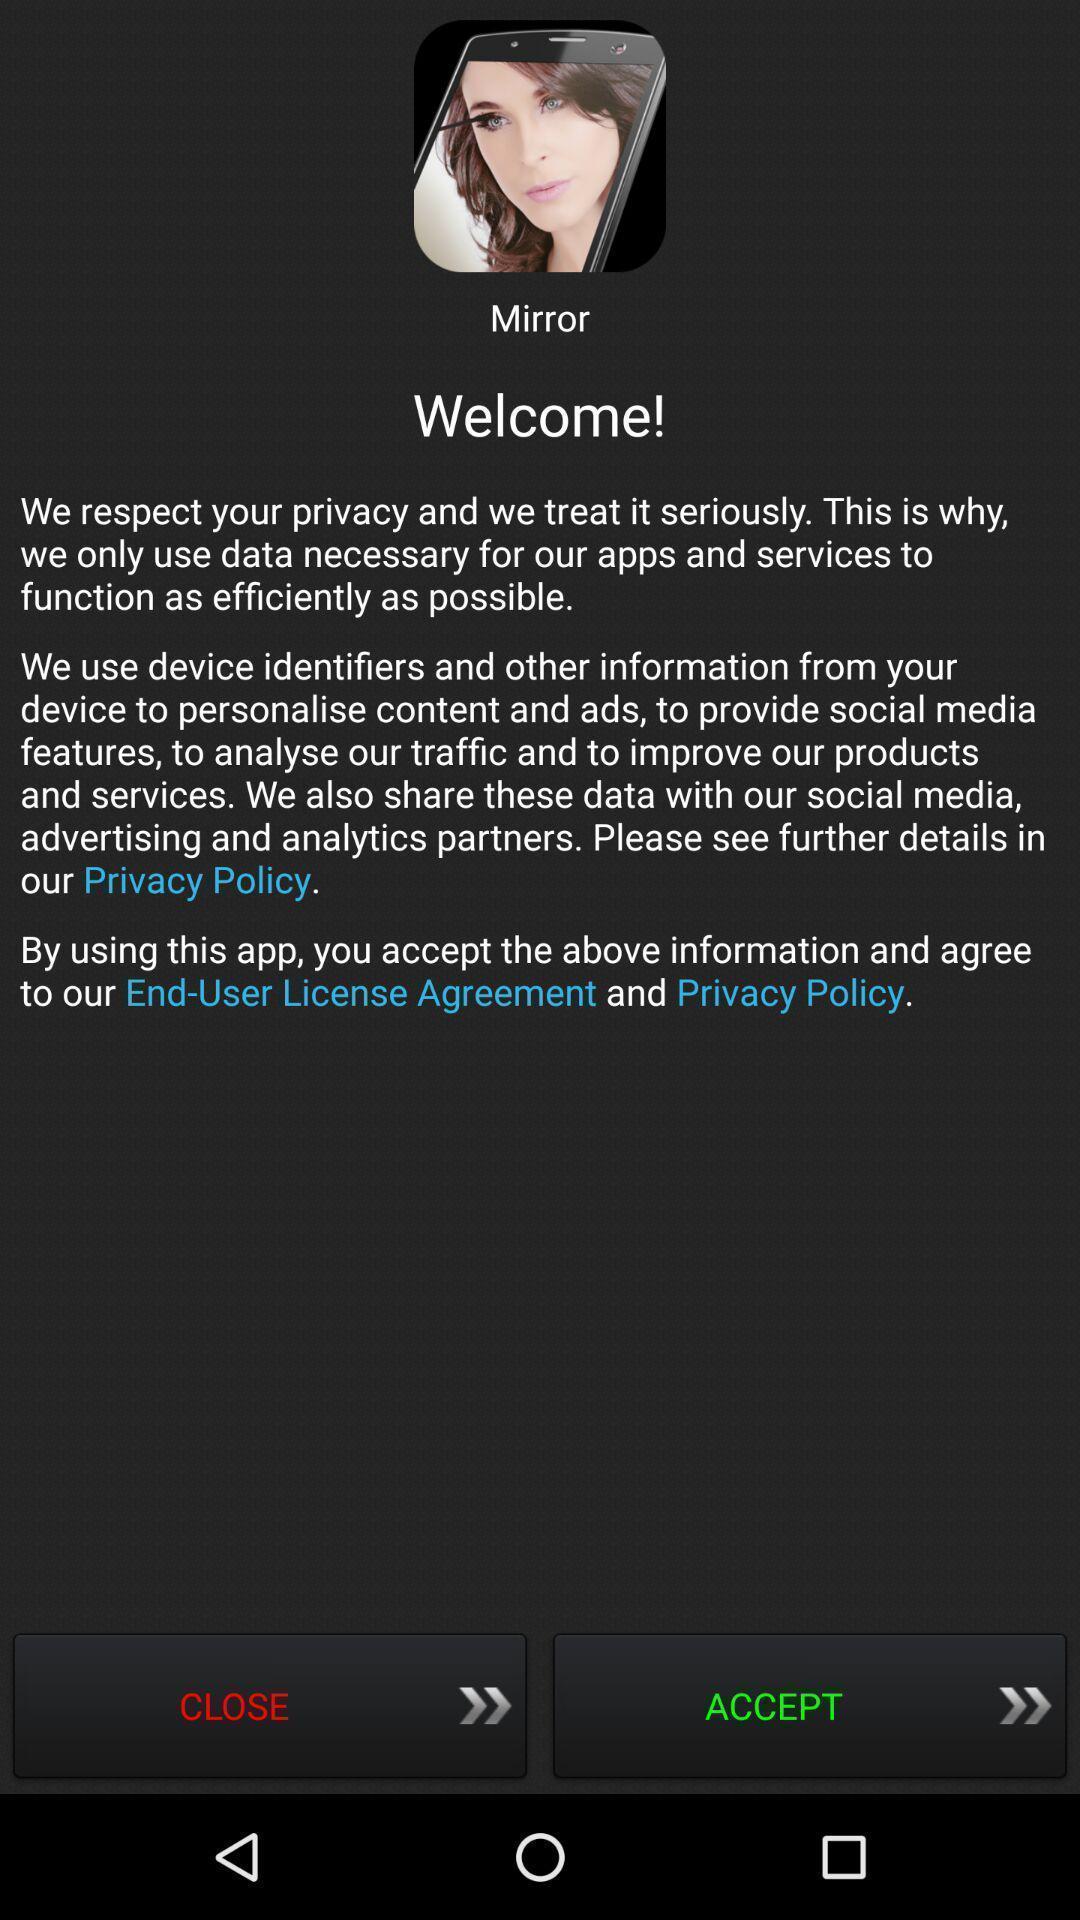Summarize the information in this screenshot. Welcome page asking to accept privacy policies. 